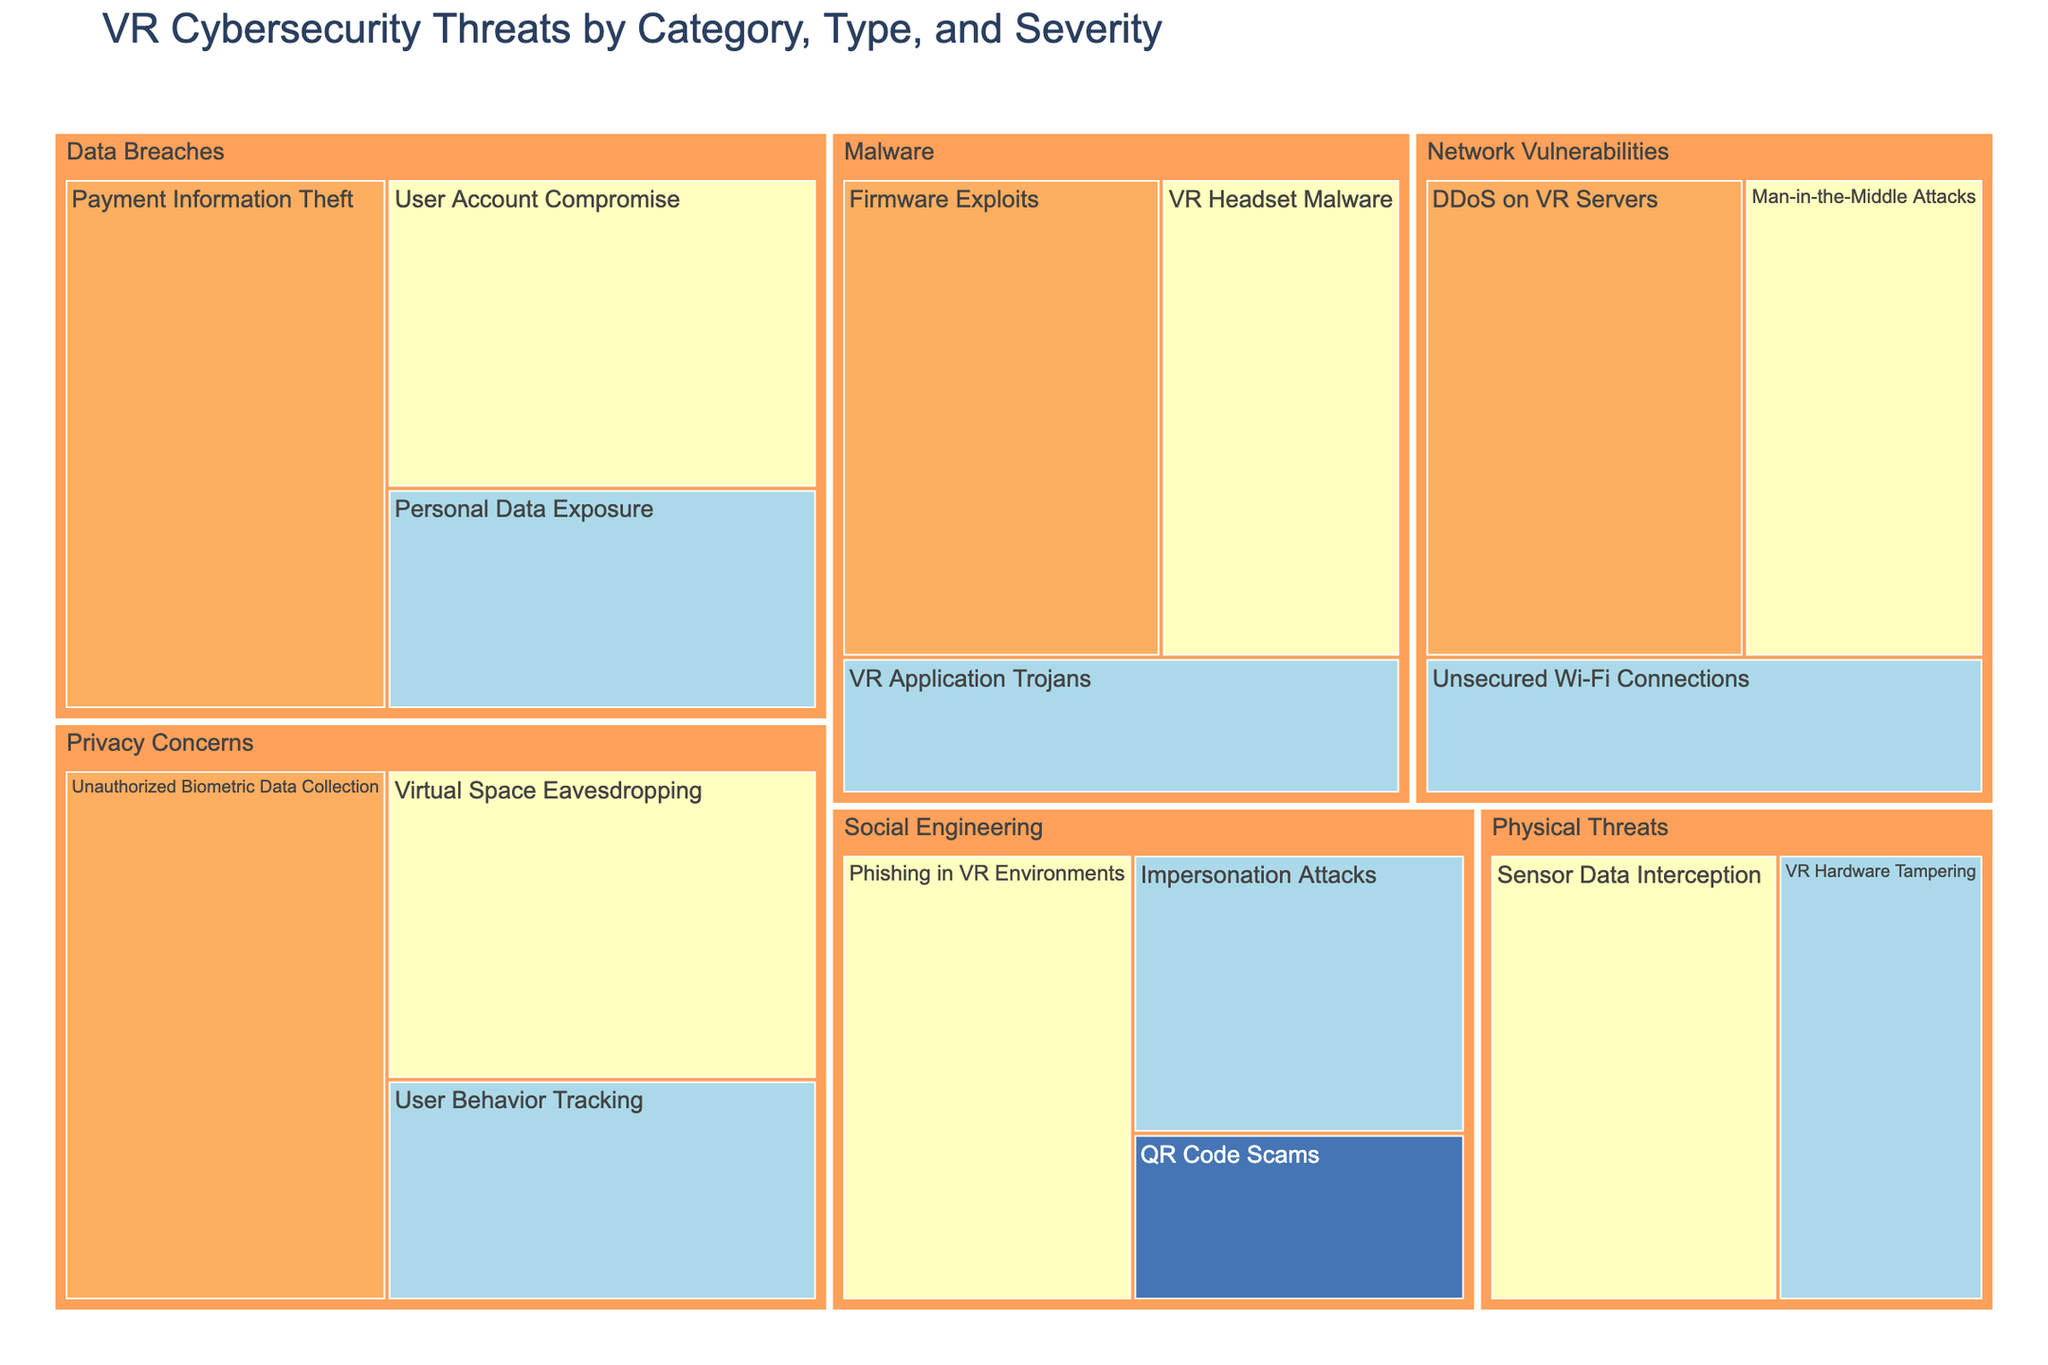What's the highest severity listed in the figure? The figure shows four levels of severity: Low, Medium, High, and Critical. "Critical" is the highest severity level among them.
Answer: Critical How many unique types of threats are categorized under "Malware"? By looking at the Malware category in the figure, we can count the individual threat types: VR Headset Malware, VR Application Trojans, and Firmware Exploits. There are 3 unique types.
Answer: 3 Which category has the highest total value of threats? To determine this, sum up the values of each type of threat under every category and compare. Data Breaches: 35 + 45 + 25 = 105, Malware: 30 + 20 + 40 = 90, Social Engineering: 35 + 25 + 15 = 75, Network Vulnerabilities: 30 + 40 + 20 = 90, Physical Threats: 25 + 35 = 60, Privacy Concerns: 45 + 35 + 25 = 105. Both Data Breaches and Privacy Concerns have the highest total value of 105.
Answer: Data Breaches and Privacy Concerns Which specific threat has the highest value in the figure? Look for the threat with the highest individual value across all categories. Payment Information Theft (Critical) and Unauthorized Biometric Data Collection (Critical) both have the highest value of 45.
Answer: Payment Information Theft and Unauthorized Biometric Data Collection What's the combined value of high severity threats in the figure? Sum the values of threats categorized as "High." User Account Compromise: 35, VR Headset Malware: 30, Phishing in VR Environments: 35, Man-in-the-Middle Attacks: 30, Sensor Data Interception: 35, Virtual Space Eavesdropping: 35. Total = 35 + 30 + 35 + 30 + 35 + 35 = 200.
Answer: 200 Compare the total value of "Critical" threats to the total value of "Low" threats. Which is greater and by how much? First, sum the values of "Critical" threats: Payment Information Theft: 45, Firmware Exploits: 40, DDoS on VR Servers: 40, Unauthorized Biometric Data Collection: 45. Total = 45 + 40 + 40 + 45 = 170. Then, the value of "Low" threats: QR Code Scams: 15. 170 - 15 = 155. "Critical" threats have a greater total value by 155.
Answer: Critical by 155 What's the total number of threat types in the figure? Count all unique threat types across all categories. There are 18 unique threat types in the figure.
Answer: 18 